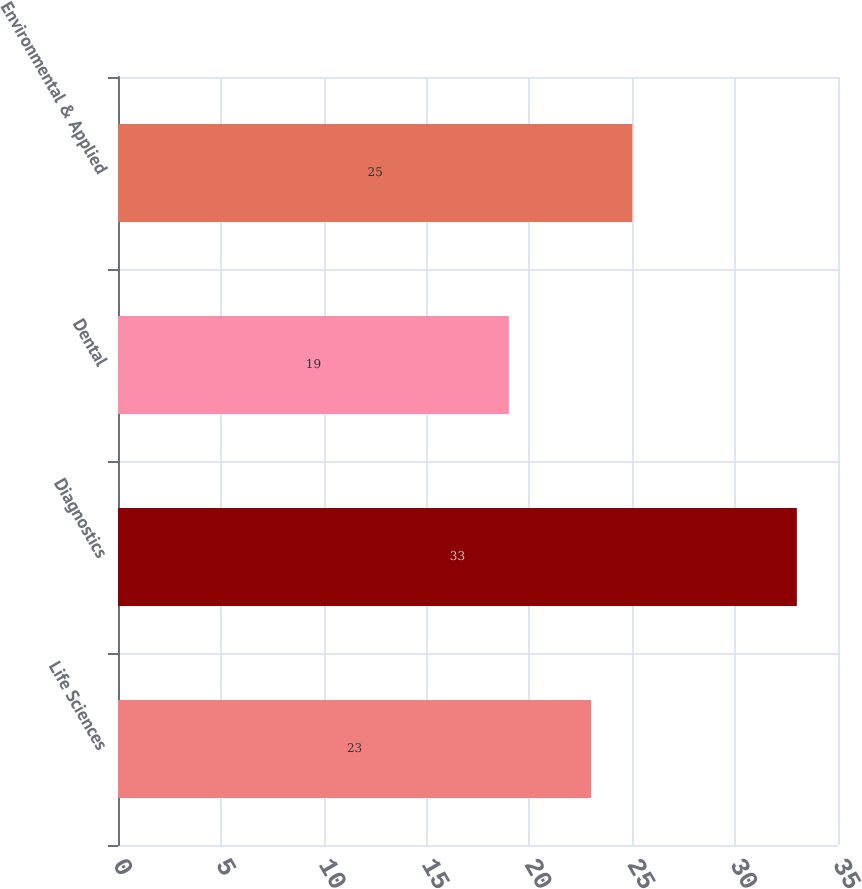<chart> <loc_0><loc_0><loc_500><loc_500><bar_chart><fcel>Life Sciences<fcel>Diagnostics<fcel>Dental<fcel>Environmental & Applied<nl><fcel>23<fcel>33<fcel>19<fcel>25<nl></chart> 